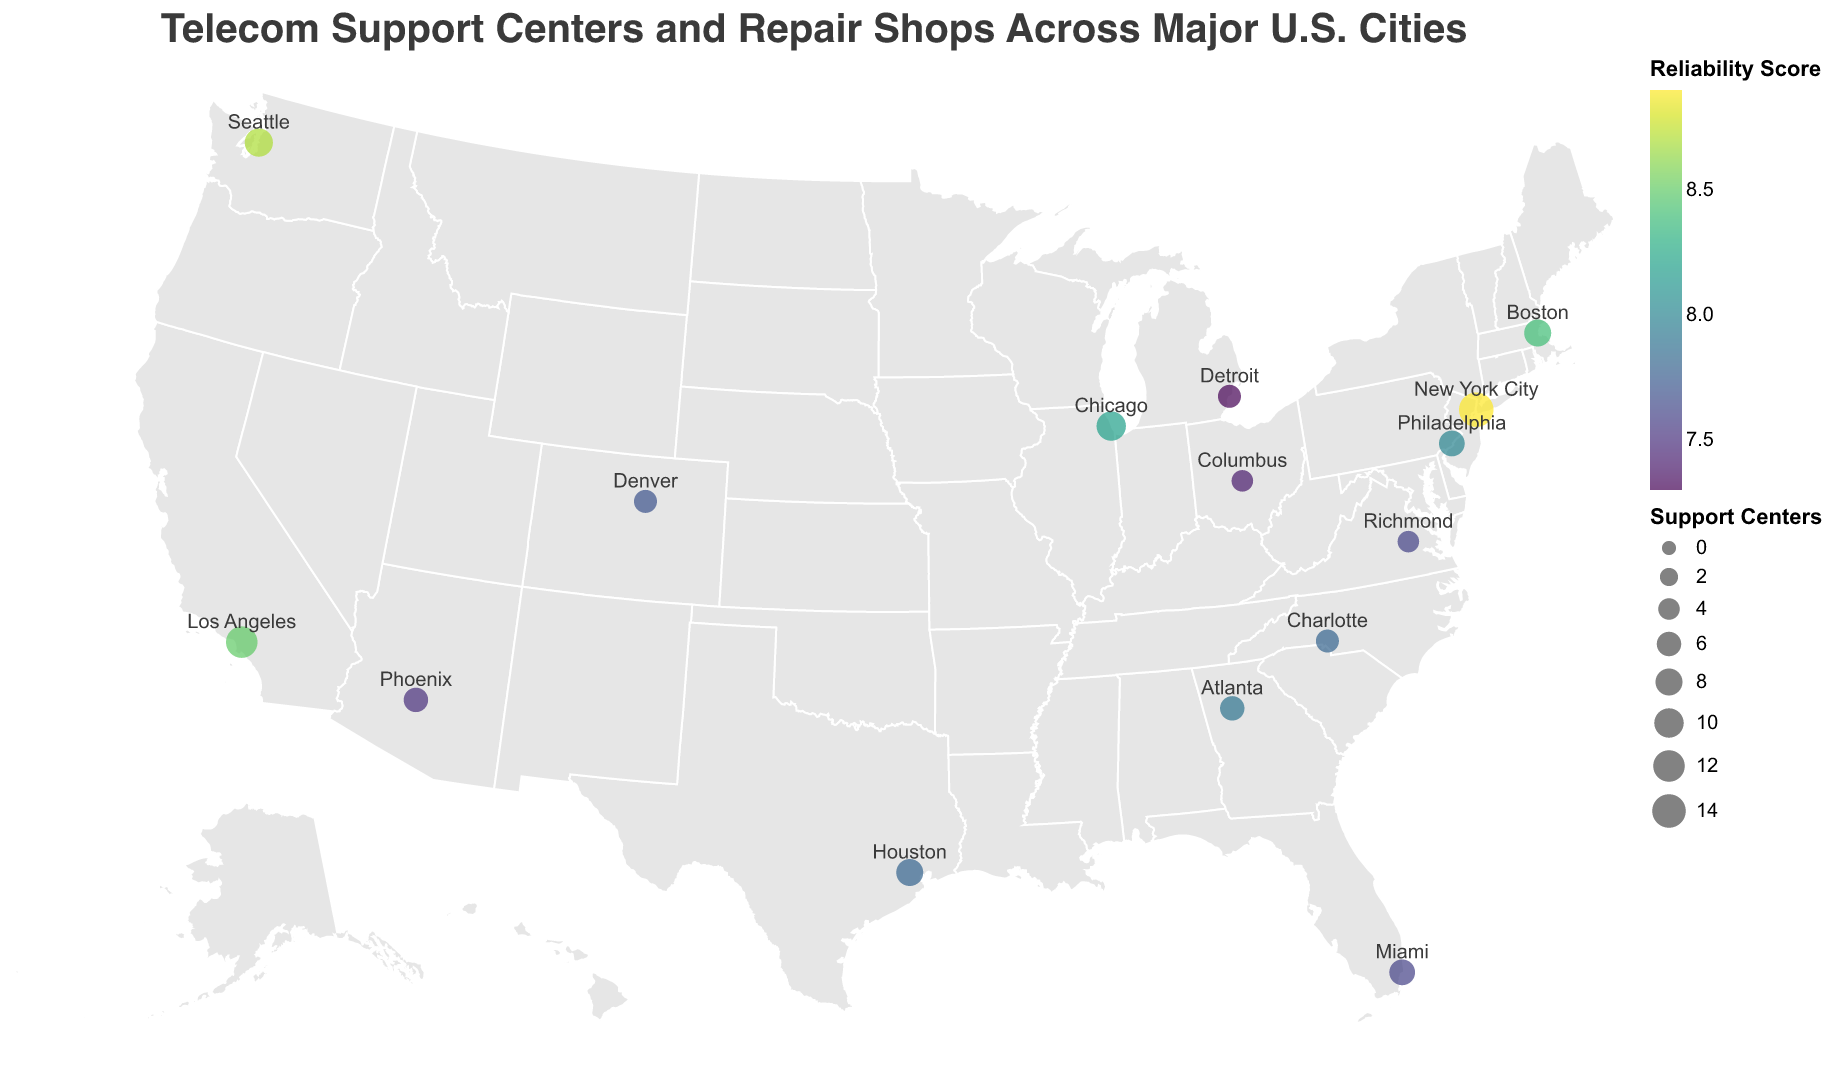What is the title of the plot? The title is displayed prominently at the top of the plot.
Answer: Telecom Support Centers and Repair Shops Across Major U.S. Cities How many support centers are there in Chicago? The tooltip or the circle size can provide this information when hovering over Chicago.
Answer: 10 Which city has the highest number of repair shops? The tooltip data shows that New York City has the highest number of repair shops at 22.
Answer: New York City Which city has the highest Telecom Reliability Score? The color scale in the legend indicates that New York City, marked with the darkest color (closest to viridis scale), has the highest score of 8.9.
Answer: New York City How many more support centers does Los Angeles have compared to Phoenix? Los Angeles has 12 support centers and Phoenix has 6, thus the difference is 12 - 6 = 6.
Answer: 6 How is the size of the circles related to the number of Support Centers? The legend indicates that circle size corresponds to the number of support centers.
Answer: Larger circles represent more support centers Which cities have a Telecom Reliability Score greater than 8.4? New York City (8.9), Seattle (8.7), Boston (8.4), and Los Angeles (8.5) have scores greater than 8.4.
Answer: New York City, Seattle, Boston, Los Angeles Compare the number of support centers and repair shops in Houston. Houston has 8 support centers and 13 repair shops as shown in the tooltip.
Answer: Support Centers: 8, Repair Shops: 13 Which city in the plot has the least number of support centers? The tooltip data shows that Columbus and Richmond both have the least number of support centers, which is 4.
Answer: Columbus, Richmond Is there a correlation between the number of support centers and the Telecom Reliability Score in the cities? Cities with more support centers, like New York City and Los Angeles, tend to have higher Telecom Reliability Scores. This suggests a positive correlation, where an increased number of support centers is associated with higher reliability scores.
Answer: Yes, there is a positive correlation 